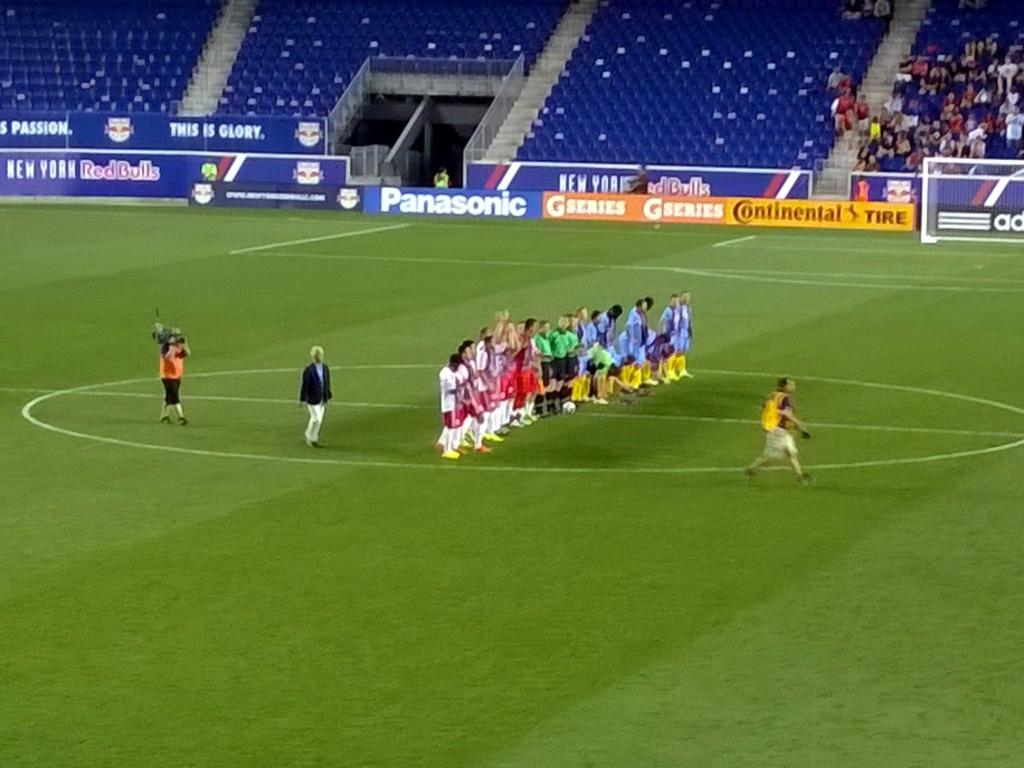<image>
Provide a brief description of the given image. Several soccer players are on the field, which has a Panasonic banner on the wall. 